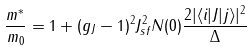Convert formula to latex. <formula><loc_0><loc_0><loc_500><loc_500>\frac { m ^ { * } } { m _ { 0 } } = 1 + ( g _ { J } - 1 ) ^ { 2 } J _ { s f } ^ { 2 } N ( 0 ) \frac { 2 | \langle i | J | j \rangle | ^ { 2 } } { \Delta }</formula> 